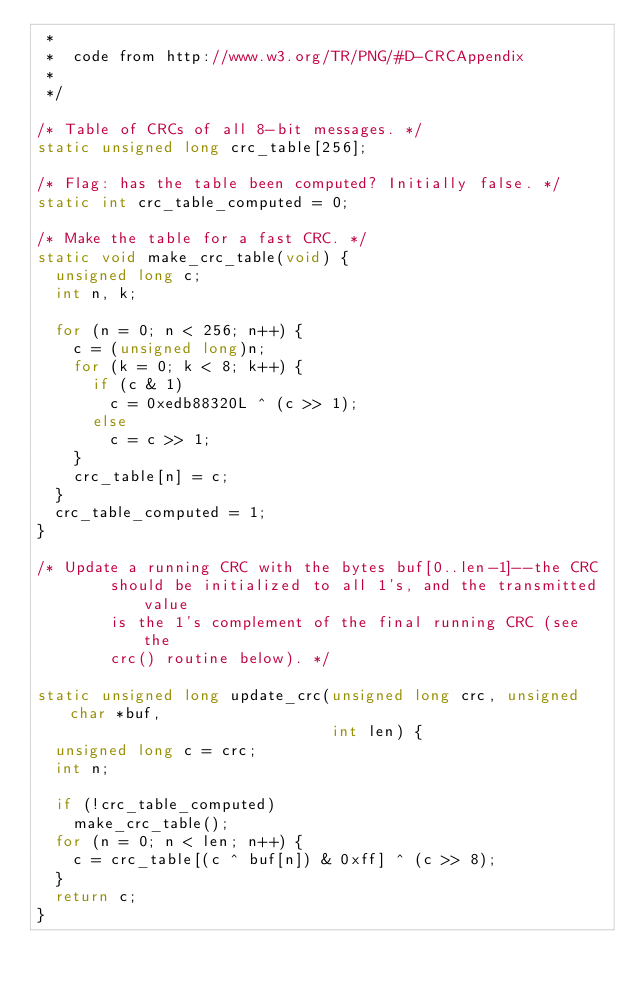Convert code to text. <code><loc_0><loc_0><loc_500><loc_500><_C_> *
 *  code from http://www.w3.org/TR/PNG/#D-CRCAppendix
 *
 */

/* Table of CRCs of all 8-bit messages. */
static unsigned long crc_table[256];

/* Flag: has the table been computed? Initially false. */
static int crc_table_computed = 0;

/* Make the table for a fast CRC. */
static void make_crc_table(void) {
  unsigned long c;
  int n, k;

  for (n = 0; n < 256; n++) {
    c = (unsigned long)n;
    for (k = 0; k < 8; k++) {
      if (c & 1)
        c = 0xedb88320L ^ (c >> 1);
      else
        c = c >> 1;
    }
    crc_table[n] = c;
  }
  crc_table_computed = 1;
}

/* Update a running CRC with the bytes buf[0..len-1]--the CRC
        should be initialized to all 1's, and the transmitted value
        is the 1's complement of the final running CRC (see the
        crc() routine below). */

static unsigned long update_crc(unsigned long crc, unsigned char *buf,
                                int len) {
  unsigned long c = crc;
  int n;

  if (!crc_table_computed)
    make_crc_table();
  for (n = 0; n < len; n++) {
    c = crc_table[(c ^ buf[n]) & 0xff] ^ (c >> 8);
  }
  return c;
}
</code> 